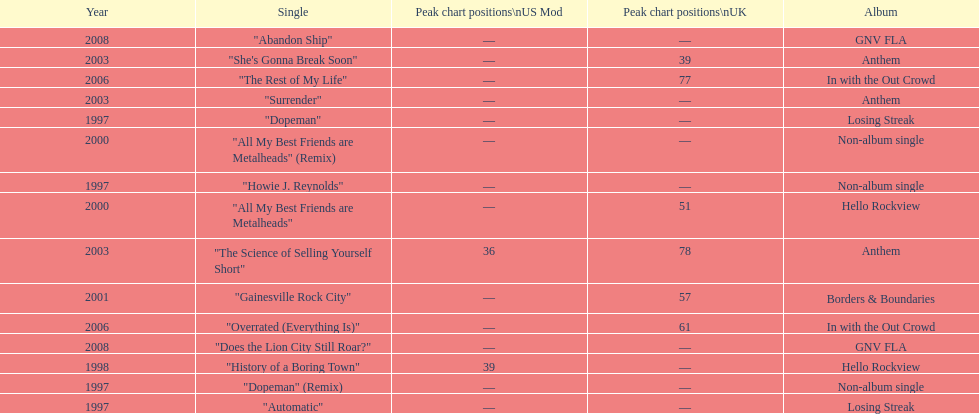How long was it between losing streak almbum and gnv fla in years. 11. 